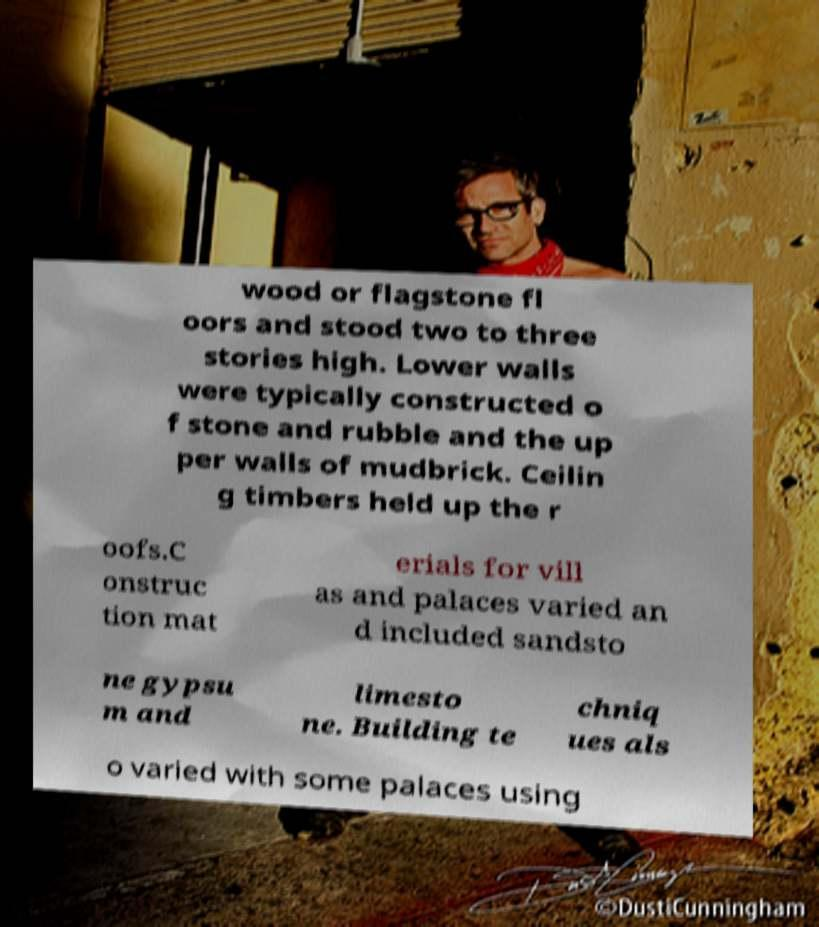What messages or text are displayed in this image? I need them in a readable, typed format. wood or flagstone fl oors and stood two to three stories high. Lower walls were typically constructed o f stone and rubble and the up per walls of mudbrick. Ceilin g timbers held up the r oofs.C onstruc tion mat erials for vill as and palaces varied an d included sandsto ne gypsu m and limesto ne. Building te chniq ues als o varied with some palaces using 